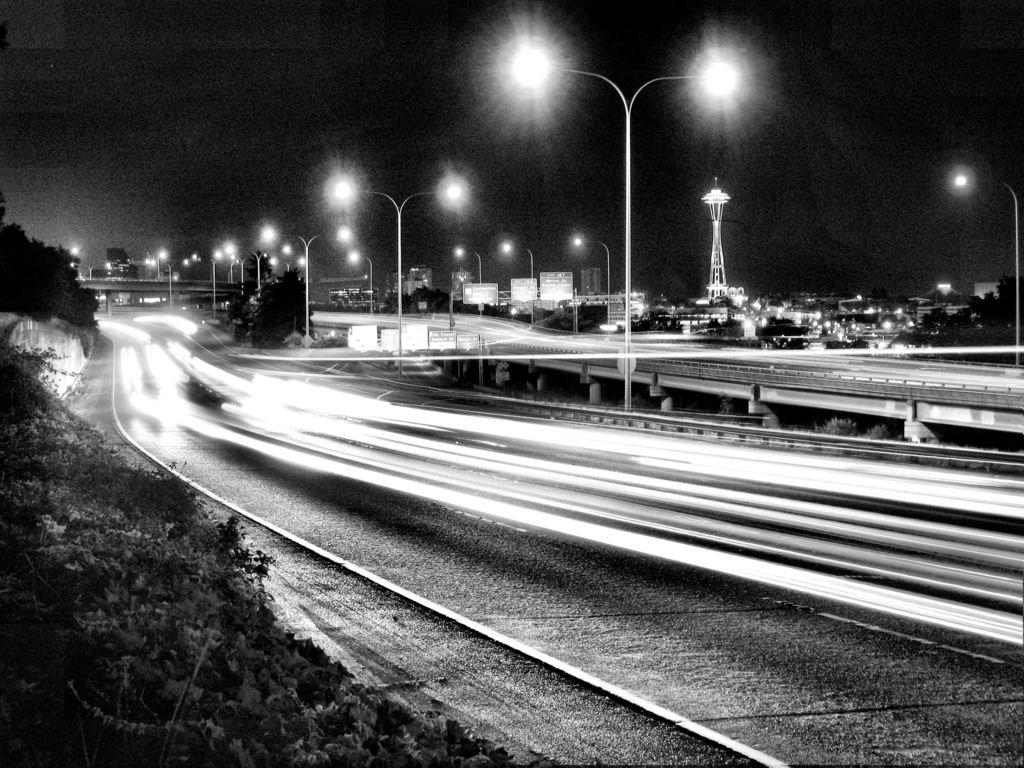What is the color scheme of the image? The image is black and white. What can be seen on the ground in the image? There is a road in the image. What type of structures are present in the image? There are lights, trees, plants, a flyover, a tower, sign boards, and buildings in the image. What celestial body is visible in the image? The moon is visible in the image. What part of the natural environment is visible in the image? The sky is visible in the image. What type of apparatus is being used by the boy in the image? There is no boy present in the image, and therefore no apparatus being used. How does the heat affect the plants in the image? The image is black and white, and there is no indication of heat or its effects on the plants. 